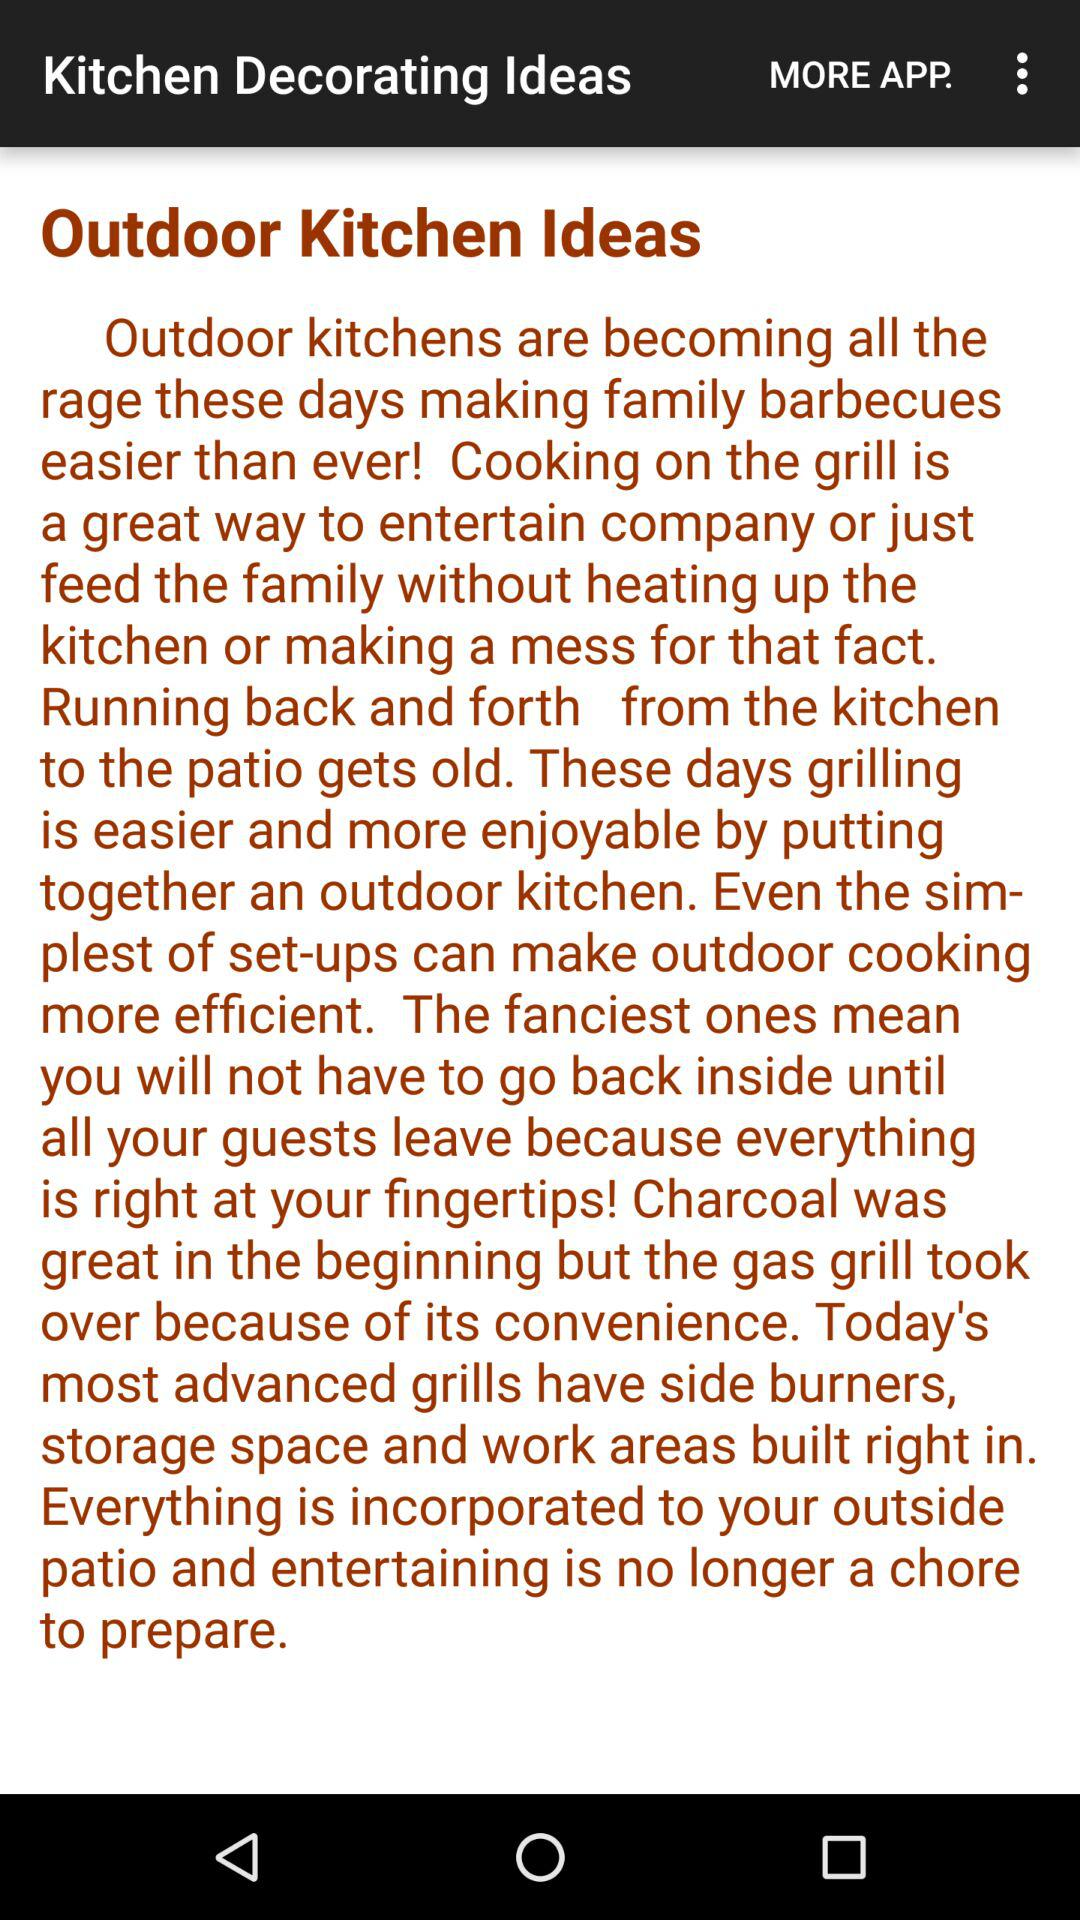What is the application name? The application name is "Kitchen Decorating Ideas". 